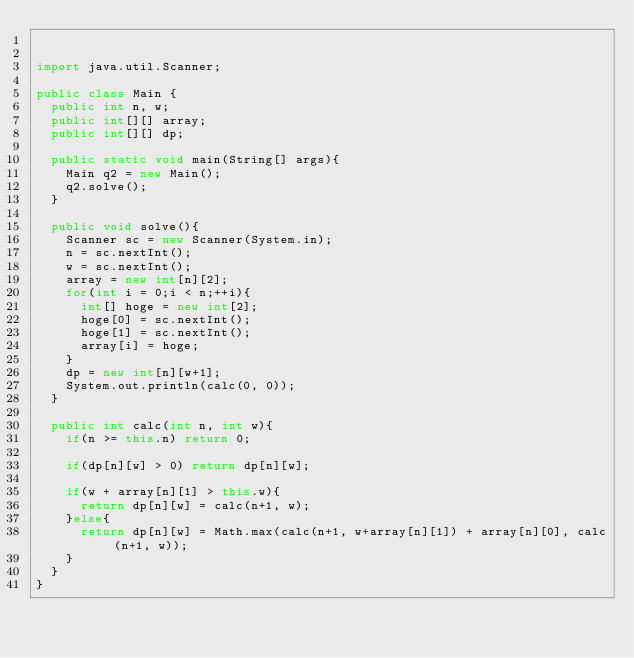Convert code to text. <code><loc_0><loc_0><loc_500><loc_500><_Java_>

import java.util.Scanner;

public class Main {
	public int n, w;
	public int[][] array;
	public int[][] dp;
	
	public static void main(String[] args){
		Main q2 = new Main();
		q2.solve();
	}
	
	public void solve(){
		Scanner sc = new Scanner(System.in);
		n = sc.nextInt();
		w = sc.nextInt();
		array = new int[n][2];
		for(int i = 0;i < n;++i){
			int[] hoge = new int[2];
			hoge[0] = sc.nextInt();
			hoge[1] = sc.nextInt();
			array[i] = hoge;
		}
		dp = new int[n][w+1];
		System.out.println(calc(0, 0));
	}
	
	public int calc(int n, int w){
		if(n >= this.n) return 0;
		
		if(dp[n][w] > 0) return dp[n][w];
		
		if(w + array[n][1] > this.w){
			return dp[n][w] = calc(n+1, w);
		}else{
			return dp[n][w] = Math.max(calc(n+1, w+array[n][1]) + array[n][0], calc(n+1, w));
		}
	}
}</code> 